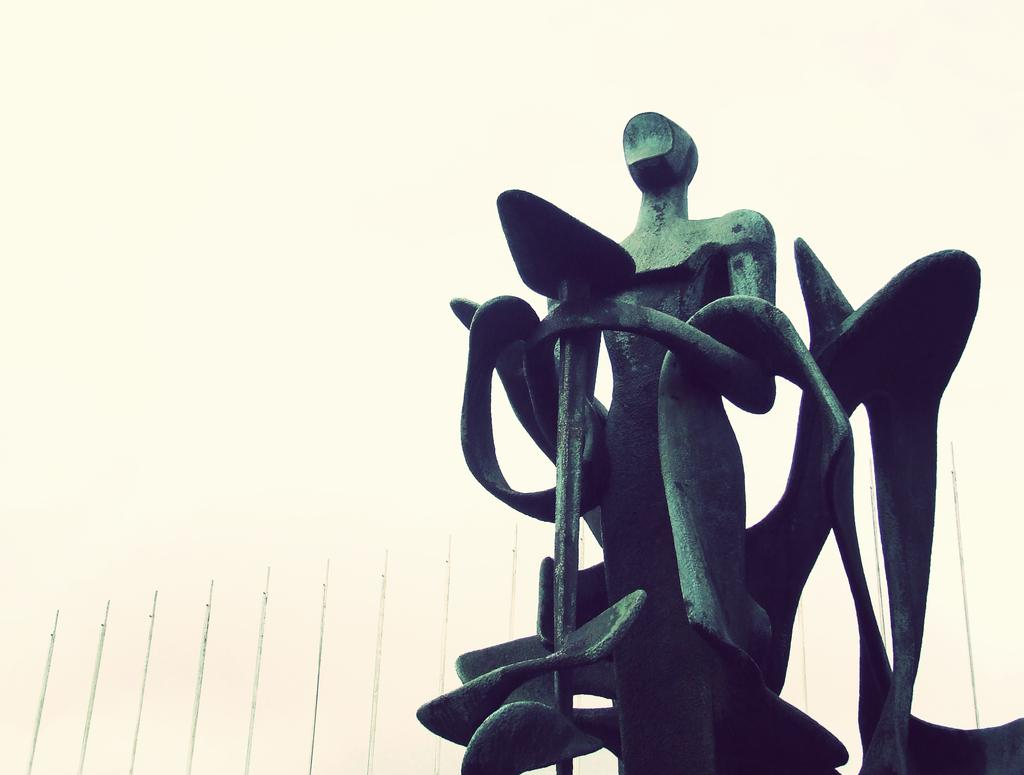What is the main subject in the image? There is a statue in the image. What other structure can be seen in the image? There is a building in the image. What is visible at the top of the image? The sky is visible at the top of the image. Can you provide an example of a dinosaur that can be seen in the image? There are no dinosaurs present in the image; it features a statue and a building. 